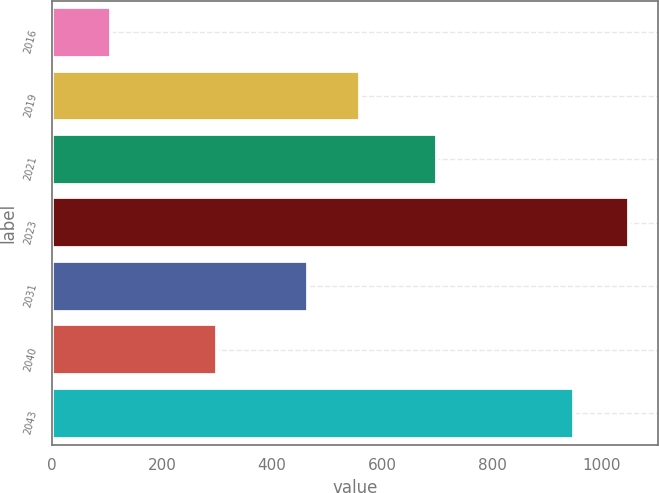Convert chart. <chart><loc_0><loc_0><loc_500><loc_500><bar_chart><fcel>2016<fcel>2019<fcel>2021<fcel>2023<fcel>2031<fcel>2040<fcel>2043<nl><fcel>107<fcel>560.3<fcel>700<fcel>1050<fcel>466<fcel>300<fcel>950<nl></chart> 